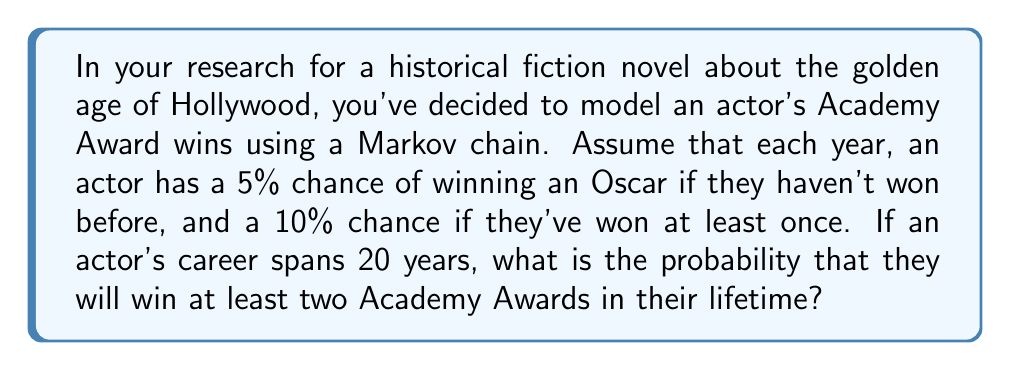Solve this math problem. Let's approach this step-by-step using a Markov chain:

1) Define states:
   State 0: No Oscar wins
   State 1: One Oscar win
   State 2: Two or more Oscar wins

2) Transition matrix:
   $$P = \begin{bmatrix}
   0.95 & 0.05 & 0 \\
   0 & 0.90 & 0.10 \\
   0 & 0 & 1
   \end{bmatrix}$$

3) Initial state vector:
   $$\pi_0 = \begin{bmatrix} 1 & 0 & 0 \end{bmatrix}$$

4) To find the probability after 20 years, we need to compute:
   $$\pi_{20} = \pi_0 P^{20}$$

5) Using matrix exponentiation:
   $$P^{20} \approx \begin{bmatrix}
   0.3585 & 0.3775 & 0.2640 \\
   0 & 0.1216 & 0.8784 \\
   0 & 0 & 1
   \end{bmatrix}$$

6) Multiplying by the initial state vector:
   $$\pi_{20} = \begin{bmatrix} 1 & 0 & 0 \end{bmatrix} \begin{bmatrix}
   0.3585 & 0.3775 & 0.2640 \\
   0 & 0.1216 & 0.8784 \\
   0 & 0 & 1
   \end{bmatrix} = \begin{bmatrix} 0.3585 & 0.3775 & 0.2640 \end{bmatrix}$$

7) The probability of winning at least two Oscars is the value in the third column: 0.2640 or 26.40%.
Answer: 0.2640 or 26.40% 